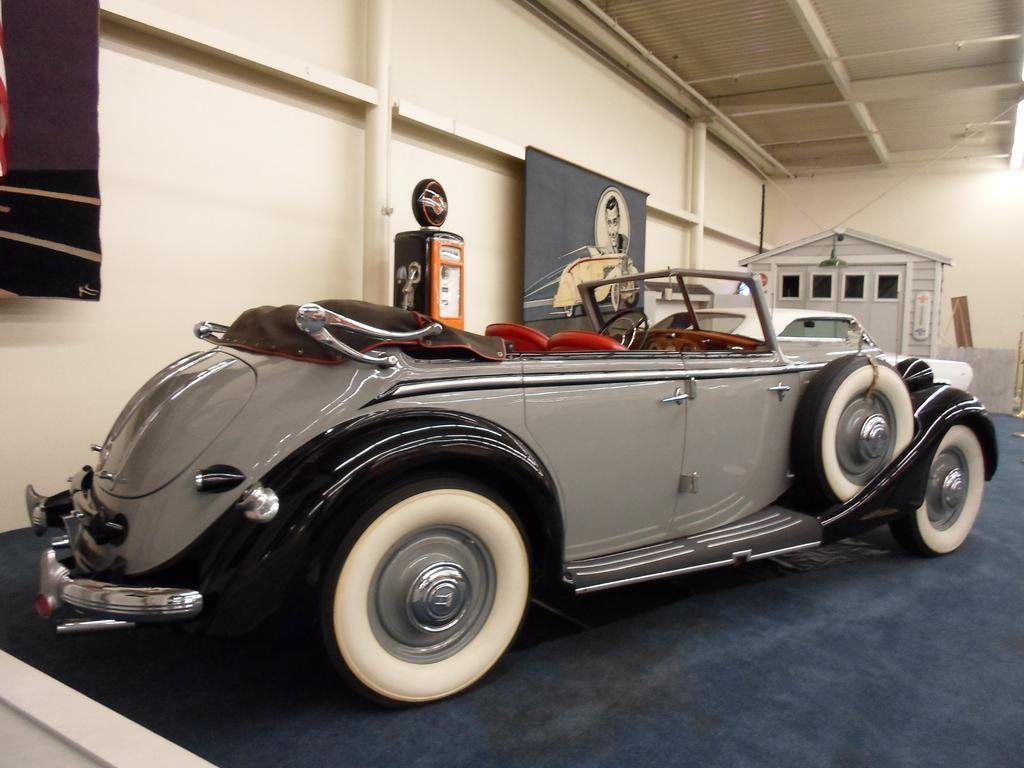How would you summarize this image in a sentence or two? This picture is taken inside the room. In this image, we can see a table, on the table, we can see a vehicle is placed. In the background, we can see a door and a hoarding, on the hoarding, we can see a picture of a person. On the left side, we can also see a cloth. At the top, we can see a roof, at the bottom, we can see blue color. 